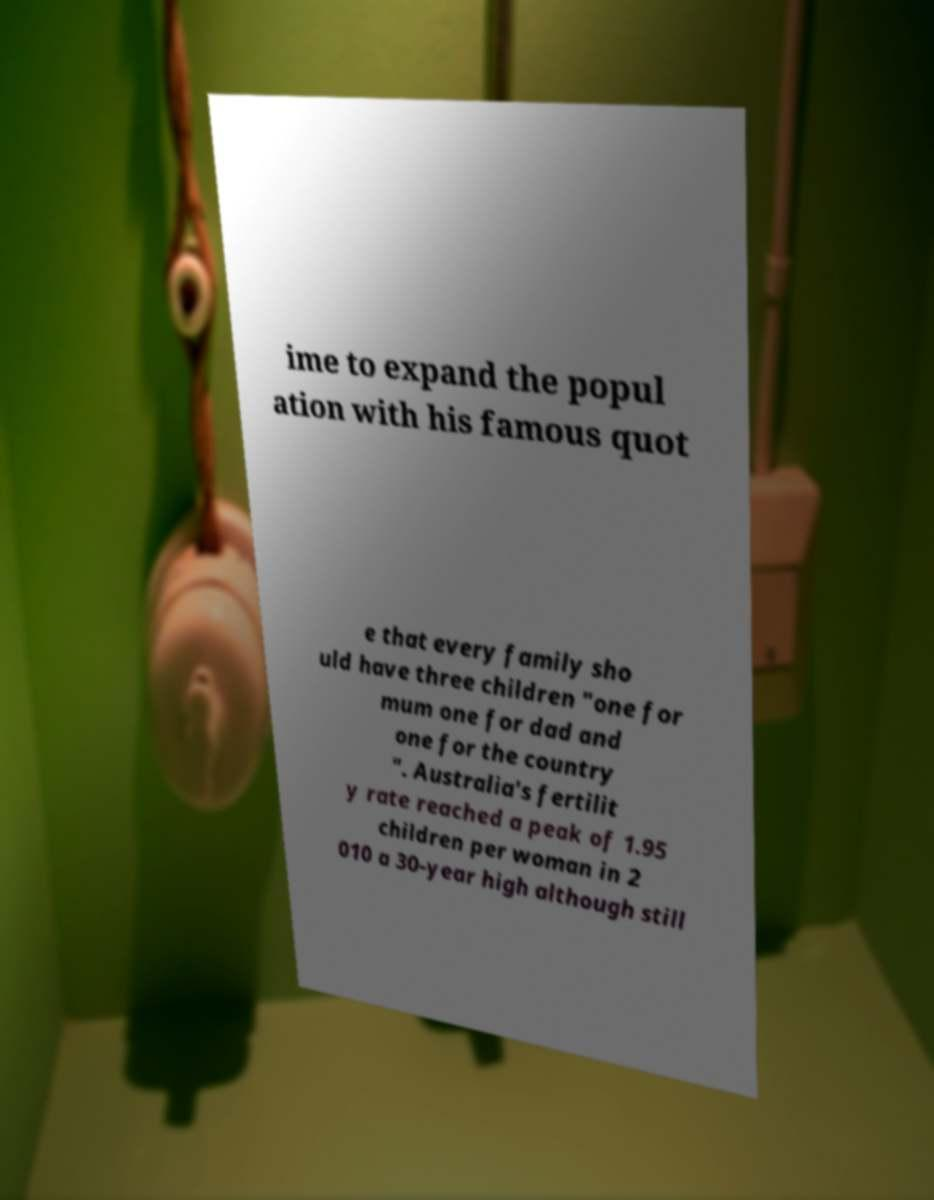Could you assist in decoding the text presented in this image and type it out clearly? ime to expand the popul ation with his famous quot e that every family sho uld have three children "one for mum one for dad and one for the country ". Australia's fertilit y rate reached a peak of 1.95 children per woman in 2 010 a 30-year high although still 